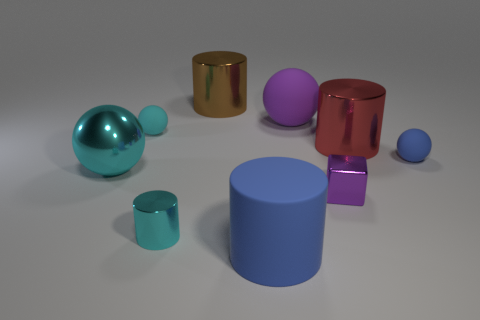The rubber ball that is the same color as the tiny metal cylinder is what size?
Your response must be concise. Small. There is a cylinder that is the same color as the shiny sphere; what is its material?
Provide a succinct answer. Metal. The metal block that is the same size as the cyan shiny cylinder is what color?
Offer a terse response. Purple. Is the size of the rubber cylinder the same as the cyan cylinder?
Your answer should be compact. No. There is a cylinder that is to the right of the large brown object and in front of the small cube; what is its size?
Make the answer very short. Large. What number of shiny things are small blue spheres or small purple cylinders?
Provide a short and direct response. 0. Is the number of tiny rubber spheres that are right of the large blue object greater than the number of purple rubber cylinders?
Give a very brief answer. Yes. There is a object that is in front of the small cyan metallic cylinder; what is it made of?
Make the answer very short. Rubber. How many small blue things have the same material as the tiny blue sphere?
Your response must be concise. 0. There is a object that is on the left side of the large blue matte thing and behind the small cyan matte thing; what shape is it?
Give a very brief answer. Cylinder. 